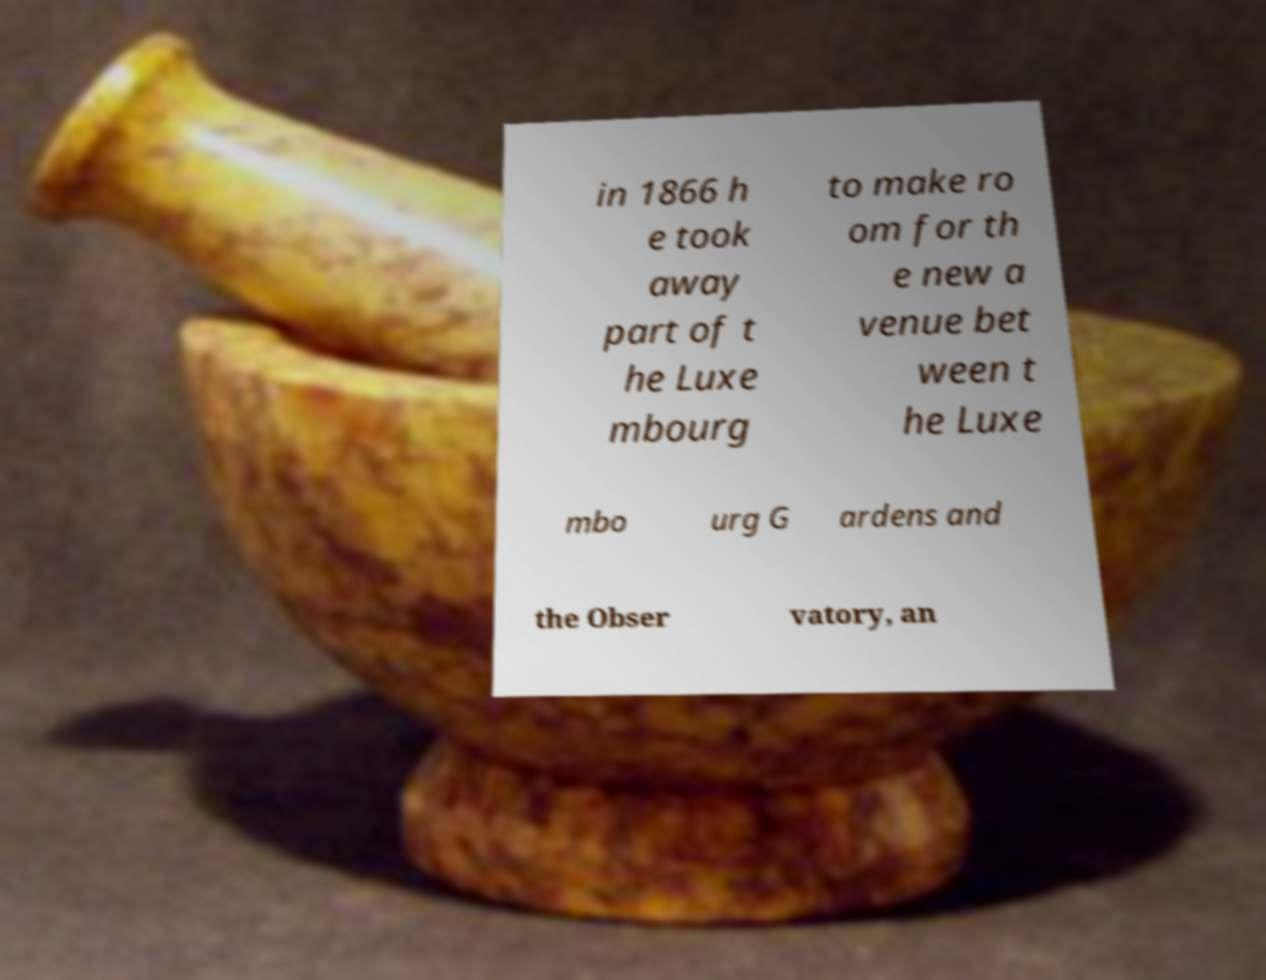What messages or text are displayed in this image? I need them in a readable, typed format. in 1866 h e took away part of t he Luxe mbourg to make ro om for th e new a venue bet ween t he Luxe mbo urg G ardens and the Obser vatory, an 